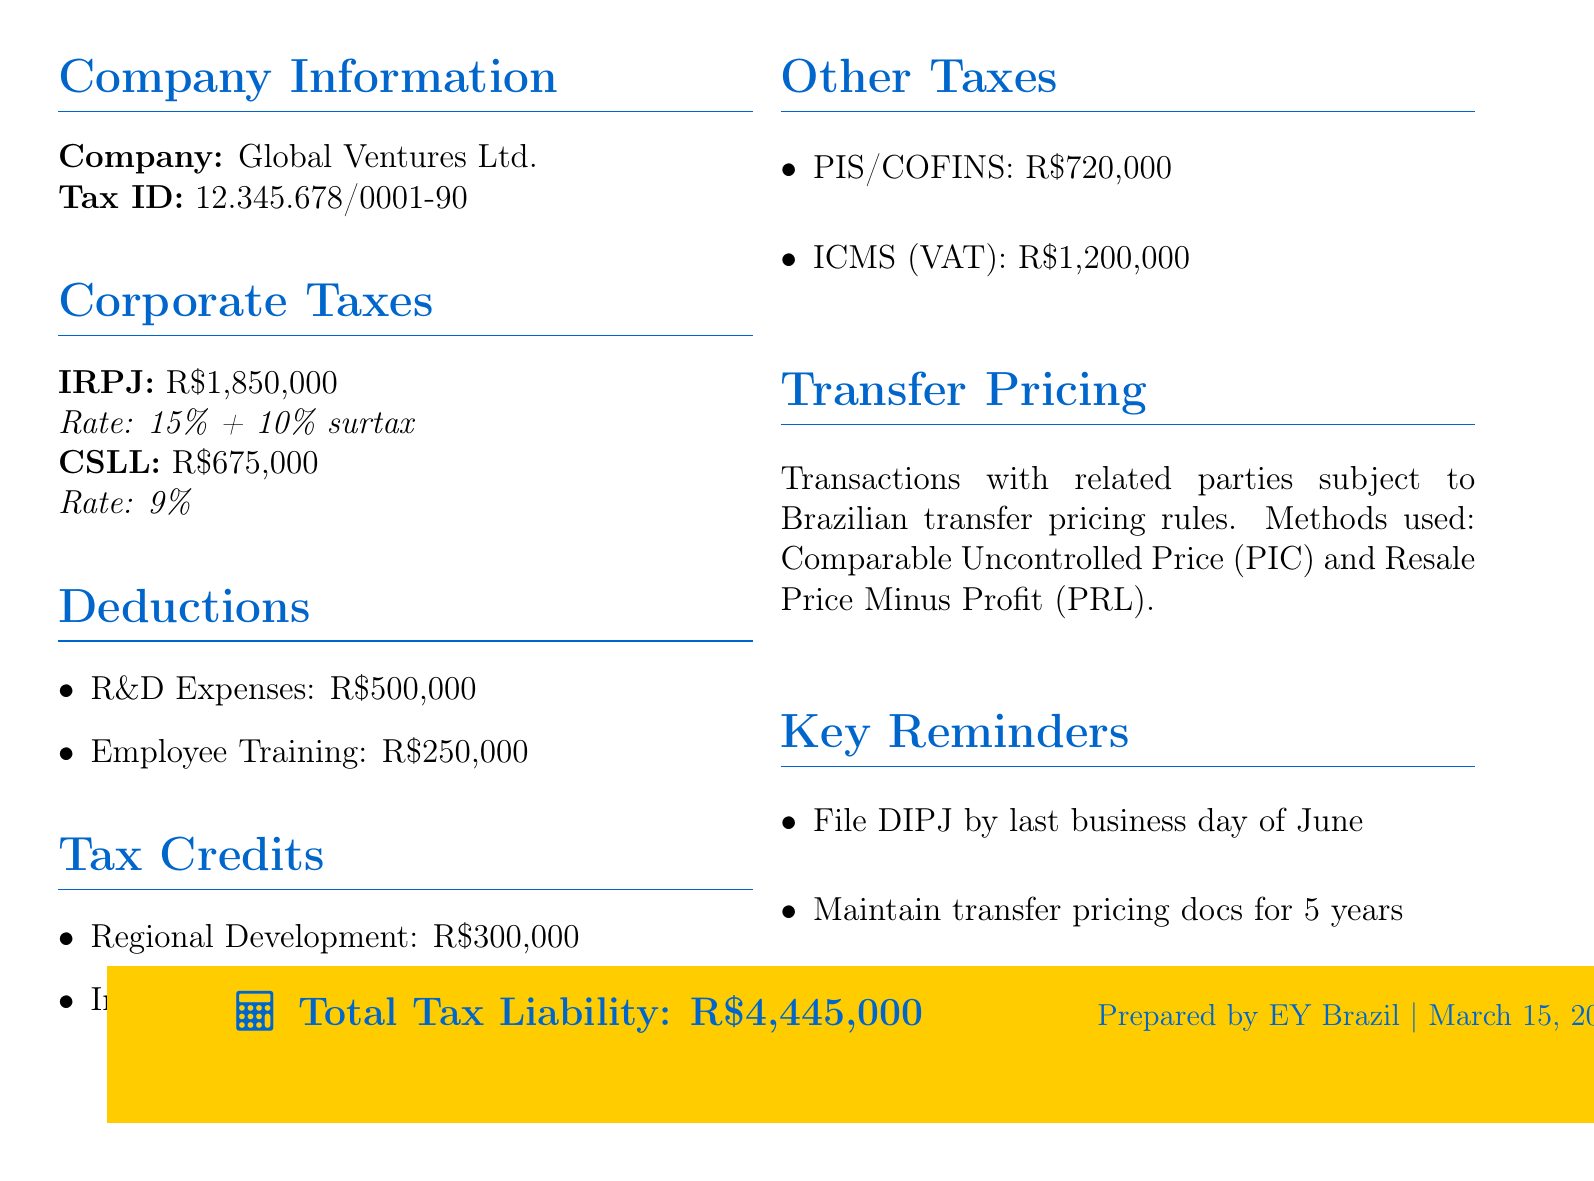What is the title of the document? The title is presented at the beginning of the document, detailing the content and subject matter.
Answer: Annual Tax Summary: Foreign Business Operations in Brazil What year does the report cover? The year in the title indicates the time frame for the financial report.
Answer: 2023 What is the corporate income tax liability? The tax liability sections specify the amounts owed for different taxes, including corporate income tax.
Answer: R$1,850,000 What is the social contribution rate on net profit? The document lists the rates alongside their respective liabilities, providing clear rates for each tax.
Answer: 9% How much was claimed for research and development expenses? The deductions section lists specific expense amounts that reduce taxable income, highlighting key deductions.
Answer: R$500,000 What is the total tax liability? The total tax liability is clearly stated at the end of the document, summarising all associated tax obligations.
Answer: R$4,445,000 Which method is used for transfer pricing considerations? The description under transfer pricing specifies the methods employed for related party transactions under Brazilian rules.
Answer: Comparable Uncontrolled Price (PIC) When is the DIPJ due? The key reminders section outlines important deadlines that must be adhered to for tax filings.
Answer: last business day of June What are the two types of tax credits listed? The tax credits section includes specific incentives that can reduce tax liabilities, identifying key credits available.
Answer: Regional Development Incentive (SUDAM/SUDENE), Innovation Law Incentive 